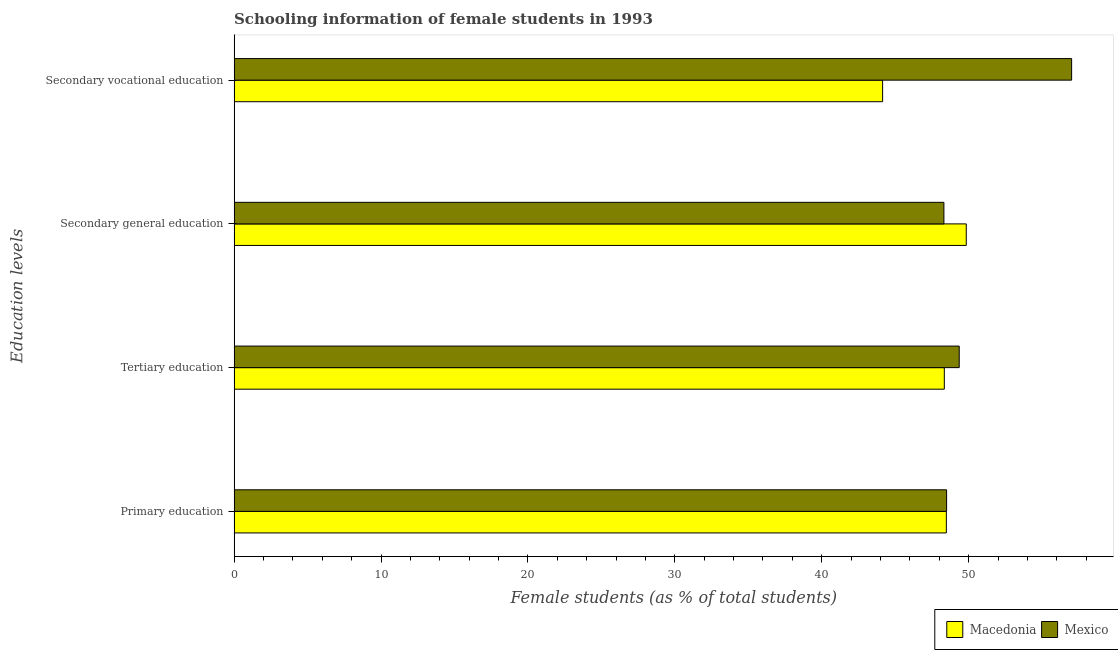Are the number of bars on each tick of the Y-axis equal?
Your answer should be very brief. Yes. How many bars are there on the 3rd tick from the top?
Provide a succinct answer. 2. What is the label of the 1st group of bars from the top?
Keep it short and to the point. Secondary vocational education. What is the percentage of female students in primary education in Macedonia?
Your answer should be compact. 48.48. Across all countries, what is the maximum percentage of female students in primary education?
Your answer should be very brief. 48.5. Across all countries, what is the minimum percentage of female students in primary education?
Your response must be concise. 48.48. In which country was the percentage of female students in primary education maximum?
Offer a very short reply. Mexico. In which country was the percentage of female students in tertiary education minimum?
Your answer should be very brief. Macedonia. What is the total percentage of female students in secondary education in the graph?
Give a very brief answer. 98.15. What is the difference between the percentage of female students in primary education in Mexico and that in Macedonia?
Your answer should be compact. 0.02. What is the difference between the percentage of female students in primary education in Mexico and the percentage of female students in secondary vocational education in Macedonia?
Provide a succinct answer. 4.36. What is the average percentage of female students in secondary vocational education per country?
Your answer should be very brief. 50.58. What is the difference between the percentage of female students in tertiary education and percentage of female students in primary education in Macedonia?
Make the answer very short. -0.14. What is the ratio of the percentage of female students in secondary vocational education in Mexico to that in Macedonia?
Provide a short and direct response. 1.29. What is the difference between the highest and the second highest percentage of female students in primary education?
Keep it short and to the point. 0.02. What is the difference between the highest and the lowest percentage of female students in secondary education?
Give a very brief answer. 1.52. Is the sum of the percentage of female students in primary education in Macedonia and Mexico greater than the maximum percentage of female students in secondary education across all countries?
Offer a very short reply. Yes. What does the 1st bar from the bottom in Tertiary education represents?
Provide a succinct answer. Macedonia. How many bars are there?
Keep it short and to the point. 8. Are all the bars in the graph horizontal?
Your answer should be very brief. Yes. How many countries are there in the graph?
Offer a very short reply. 2. Does the graph contain any zero values?
Keep it short and to the point. No. Does the graph contain grids?
Make the answer very short. No. Where does the legend appear in the graph?
Offer a very short reply. Bottom right. What is the title of the graph?
Give a very brief answer. Schooling information of female students in 1993. What is the label or title of the X-axis?
Your response must be concise. Female students (as % of total students). What is the label or title of the Y-axis?
Give a very brief answer. Education levels. What is the Female students (as % of total students) in Macedonia in Primary education?
Keep it short and to the point. 48.48. What is the Female students (as % of total students) of Mexico in Primary education?
Offer a very short reply. 48.5. What is the Female students (as % of total students) in Macedonia in Tertiary education?
Provide a short and direct response. 48.34. What is the Female students (as % of total students) in Mexico in Tertiary education?
Provide a succinct answer. 49.36. What is the Female students (as % of total students) in Macedonia in Secondary general education?
Keep it short and to the point. 49.84. What is the Female students (as % of total students) in Mexico in Secondary general education?
Offer a very short reply. 48.32. What is the Female students (as % of total students) of Macedonia in Secondary vocational education?
Give a very brief answer. 44.14. What is the Female students (as % of total students) of Mexico in Secondary vocational education?
Ensure brevity in your answer.  57.01. Across all Education levels, what is the maximum Female students (as % of total students) of Macedonia?
Give a very brief answer. 49.84. Across all Education levels, what is the maximum Female students (as % of total students) of Mexico?
Ensure brevity in your answer.  57.01. Across all Education levels, what is the minimum Female students (as % of total students) in Macedonia?
Keep it short and to the point. 44.14. Across all Education levels, what is the minimum Female students (as % of total students) in Mexico?
Your response must be concise. 48.32. What is the total Female students (as % of total students) in Macedonia in the graph?
Offer a terse response. 190.81. What is the total Female students (as % of total students) of Mexico in the graph?
Provide a short and direct response. 203.18. What is the difference between the Female students (as % of total students) of Macedonia in Primary education and that in Tertiary education?
Give a very brief answer. 0.14. What is the difference between the Female students (as % of total students) in Mexico in Primary education and that in Tertiary education?
Keep it short and to the point. -0.86. What is the difference between the Female students (as % of total students) in Macedonia in Primary education and that in Secondary general education?
Offer a terse response. -1.36. What is the difference between the Female students (as % of total students) of Mexico in Primary education and that in Secondary general education?
Offer a very short reply. 0.18. What is the difference between the Female students (as % of total students) in Macedonia in Primary education and that in Secondary vocational education?
Give a very brief answer. 4.34. What is the difference between the Female students (as % of total students) in Mexico in Primary education and that in Secondary vocational education?
Provide a short and direct response. -8.51. What is the difference between the Female students (as % of total students) of Macedonia in Tertiary education and that in Secondary general education?
Offer a terse response. -1.49. What is the difference between the Female students (as % of total students) in Mexico in Tertiary education and that in Secondary general education?
Ensure brevity in your answer.  1.04. What is the difference between the Female students (as % of total students) in Macedonia in Tertiary education and that in Secondary vocational education?
Keep it short and to the point. 4.2. What is the difference between the Female students (as % of total students) of Mexico in Tertiary education and that in Secondary vocational education?
Provide a succinct answer. -7.65. What is the difference between the Female students (as % of total students) in Macedonia in Secondary general education and that in Secondary vocational education?
Offer a terse response. 5.7. What is the difference between the Female students (as % of total students) of Mexico in Secondary general education and that in Secondary vocational education?
Offer a terse response. -8.69. What is the difference between the Female students (as % of total students) of Macedonia in Primary education and the Female students (as % of total students) of Mexico in Tertiary education?
Provide a succinct answer. -0.88. What is the difference between the Female students (as % of total students) in Macedonia in Primary education and the Female students (as % of total students) in Mexico in Secondary general education?
Your response must be concise. 0.17. What is the difference between the Female students (as % of total students) in Macedonia in Primary education and the Female students (as % of total students) in Mexico in Secondary vocational education?
Offer a very short reply. -8.53. What is the difference between the Female students (as % of total students) in Macedonia in Tertiary education and the Female students (as % of total students) in Mexico in Secondary general education?
Your response must be concise. 0.03. What is the difference between the Female students (as % of total students) of Macedonia in Tertiary education and the Female students (as % of total students) of Mexico in Secondary vocational education?
Ensure brevity in your answer.  -8.67. What is the difference between the Female students (as % of total students) in Macedonia in Secondary general education and the Female students (as % of total students) in Mexico in Secondary vocational education?
Provide a succinct answer. -7.17. What is the average Female students (as % of total students) of Macedonia per Education levels?
Offer a very short reply. 47.7. What is the average Female students (as % of total students) in Mexico per Education levels?
Your response must be concise. 50.8. What is the difference between the Female students (as % of total students) in Macedonia and Female students (as % of total students) in Mexico in Primary education?
Provide a short and direct response. -0.02. What is the difference between the Female students (as % of total students) in Macedonia and Female students (as % of total students) in Mexico in Tertiary education?
Your response must be concise. -1.01. What is the difference between the Female students (as % of total students) in Macedonia and Female students (as % of total students) in Mexico in Secondary general education?
Your response must be concise. 1.52. What is the difference between the Female students (as % of total students) of Macedonia and Female students (as % of total students) of Mexico in Secondary vocational education?
Keep it short and to the point. -12.87. What is the ratio of the Female students (as % of total students) in Mexico in Primary education to that in Tertiary education?
Offer a terse response. 0.98. What is the ratio of the Female students (as % of total students) in Macedonia in Primary education to that in Secondary general education?
Offer a very short reply. 0.97. What is the ratio of the Female students (as % of total students) of Macedonia in Primary education to that in Secondary vocational education?
Give a very brief answer. 1.1. What is the ratio of the Female students (as % of total students) in Mexico in Primary education to that in Secondary vocational education?
Make the answer very short. 0.85. What is the ratio of the Female students (as % of total students) of Macedonia in Tertiary education to that in Secondary general education?
Your answer should be compact. 0.97. What is the ratio of the Female students (as % of total students) of Mexico in Tertiary education to that in Secondary general education?
Your response must be concise. 1.02. What is the ratio of the Female students (as % of total students) of Macedonia in Tertiary education to that in Secondary vocational education?
Ensure brevity in your answer.  1.1. What is the ratio of the Female students (as % of total students) in Mexico in Tertiary education to that in Secondary vocational education?
Provide a short and direct response. 0.87. What is the ratio of the Female students (as % of total students) of Macedonia in Secondary general education to that in Secondary vocational education?
Provide a succinct answer. 1.13. What is the ratio of the Female students (as % of total students) of Mexico in Secondary general education to that in Secondary vocational education?
Your answer should be very brief. 0.85. What is the difference between the highest and the second highest Female students (as % of total students) in Macedonia?
Your answer should be very brief. 1.36. What is the difference between the highest and the second highest Female students (as % of total students) of Mexico?
Offer a terse response. 7.65. What is the difference between the highest and the lowest Female students (as % of total students) in Macedonia?
Offer a very short reply. 5.7. What is the difference between the highest and the lowest Female students (as % of total students) of Mexico?
Keep it short and to the point. 8.69. 